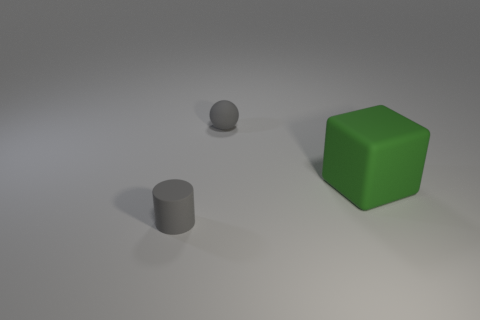What number of cubes are either tiny red objects or small gray objects?
Give a very brief answer. 0. The large cube is what color?
Provide a short and direct response. Green. Is the number of cyan matte objects greater than the number of tiny spheres?
Provide a short and direct response. No. What number of things are either rubber objects left of the big green matte cube or large green matte objects?
Offer a very short reply. 3. Does the tiny gray cylinder have the same material as the ball?
Your answer should be compact. Yes. Does the big green rubber thing that is to the right of the tiny matte cylinder have the same shape as the small thing behind the tiny cylinder?
Your answer should be very brief. No. Do the green rubber thing and the rubber object in front of the green cube have the same size?
Your response must be concise. No. What number of other objects are the same material as the big green object?
Keep it short and to the point. 2. Are there any other things that have the same shape as the green rubber thing?
Offer a terse response. No. What color is the tiny matte thing that is in front of the large green rubber thing behind the small object that is in front of the green block?
Ensure brevity in your answer.  Gray. 